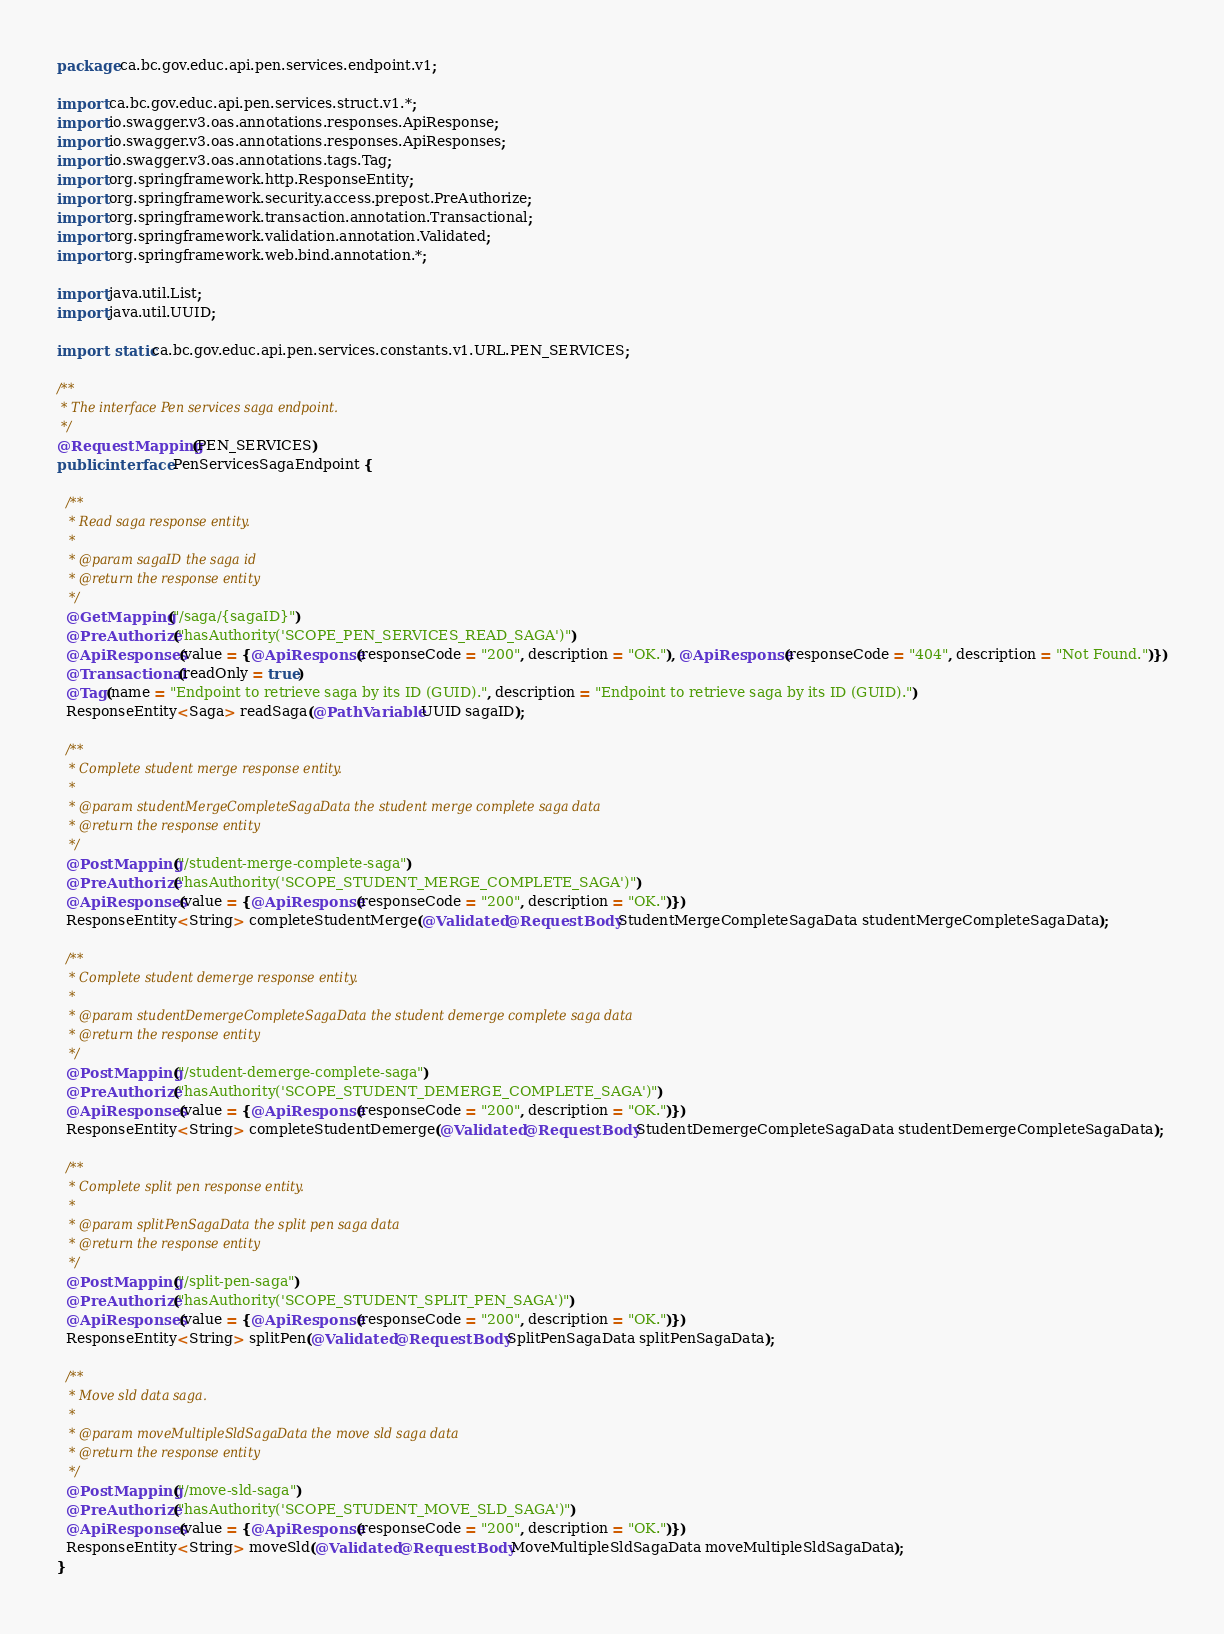Convert code to text. <code><loc_0><loc_0><loc_500><loc_500><_Java_>package ca.bc.gov.educ.api.pen.services.endpoint.v1;

import ca.bc.gov.educ.api.pen.services.struct.v1.*;
import io.swagger.v3.oas.annotations.responses.ApiResponse;
import io.swagger.v3.oas.annotations.responses.ApiResponses;
import io.swagger.v3.oas.annotations.tags.Tag;
import org.springframework.http.ResponseEntity;
import org.springframework.security.access.prepost.PreAuthorize;
import org.springframework.transaction.annotation.Transactional;
import org.springframework.validation.annotation.Validated;
import org.springframework.web.bind.annotation.*;

import java.util.List;
import java.util.UUID;

import static ca.bc.gov.educ.api.pen.services.constants.v1.URL.PEN_SERVICES;

/**
 * The interface Pen services saga endpoint.
 */
@RequestMapping(PEN_SERVICES)
public interface PenServicesSagaEndpoint {

  /**
   * Read saga response entity.
   *
   * @param sagaID the saga id
   * @return the response entity
   */
  @GetMapping("/saga/{sagaID}")
  @PreAuthorize("hasAuthority('SCOPE_PEN_SERVICES_READ_SAGA')")
  @ApiResponses(value = {@ApiResponse(responseCode = "200", description = "OK."), @ApiResponse(responseCode = "404", description = "Not Found.")})
  @Transactional(readOnly = true)
  @Tag(name = "Endpoint to retrieve saga by its ID (GUID).", description = "Endpoint to retrieve saga by its ID (GUID).")
  ResponseEntity<Saga> readSaga(@PathVariable UUID sagaID);

  /**
   * Complete student merge response entity.
   *
   * @param studentMergeCompleteSagaData the student merge complete saga data
   * @return the response entity
   */
  @PostMapping("/student-merge-complete-saga")
  @PreAuthorize("hasAuthority('SCOPE_STUDENT_MERGE_COMPLETE_SAGA')")
  @ApiResponses(value = {@ApiResponse(responseCode = "200", description = "OK.")})
  ResponseEntity<String> completeStudentMerge(@Validated @RequestBody StudentMergeCompleteSagaData studentMergeCompleteSagaData);

  /**
   * Complete student demerge response entity.
   *
   * @param studentDemergeCompleteSagaData the student demerge complete saga data
   * @return the response entity
   */
  @PostMapping("/student-demerge-complete-saga")
  @PreAuthorize("hasAuthority('SCOPE_STUDENT_DEMERGE_COMPLETE_SAGA')")
  @ApiResponses(value = {@ApiResponse(responseCode = "200", description = "OK.")})
  ResponseEntity<String> completeStudentDemerge(@Validated @RequestBody StudentDemergeCompleteSagaData studentDemergeCompleteSagaData);

  /**
   * Complete split pen response entity.
   *
   * @param splitPenSagaData the split pen saga data
   * @return the response entity
   */
  @PostMapping("/split-pen-saga")
  @PreAuthorize("hasAuthority('SCOPE_STUDENT_SPLIT_PEN_SAGA')")
  @ApiResponses(value = {@ApiResponse(responseCode = "200", description = "OK.")})
  ResponseEntity<String> splitPen(@Validated @RequestBody SplitPenSagaData splitPenSagaData);

  /**
   * Move sld data saga.
   *
   * @param moveMultipleSldSagaData the move sld saga data
   * @return the response entity
   */
  @PostMapping("/move-sld-saga")
  @PreAuthorize("hasAuthority('SCOPE_STUDENT_MOVE_SLD_SAGA')")
  @ApiResponses(value = {@ApiResponse(responseCode = "200", description = "OK.")})
  ResponseEntity<String> moveSld(@Validated @RequestBody MoveMultipleSldSagaData moveMultipleSldSagaData);
}
</code> 